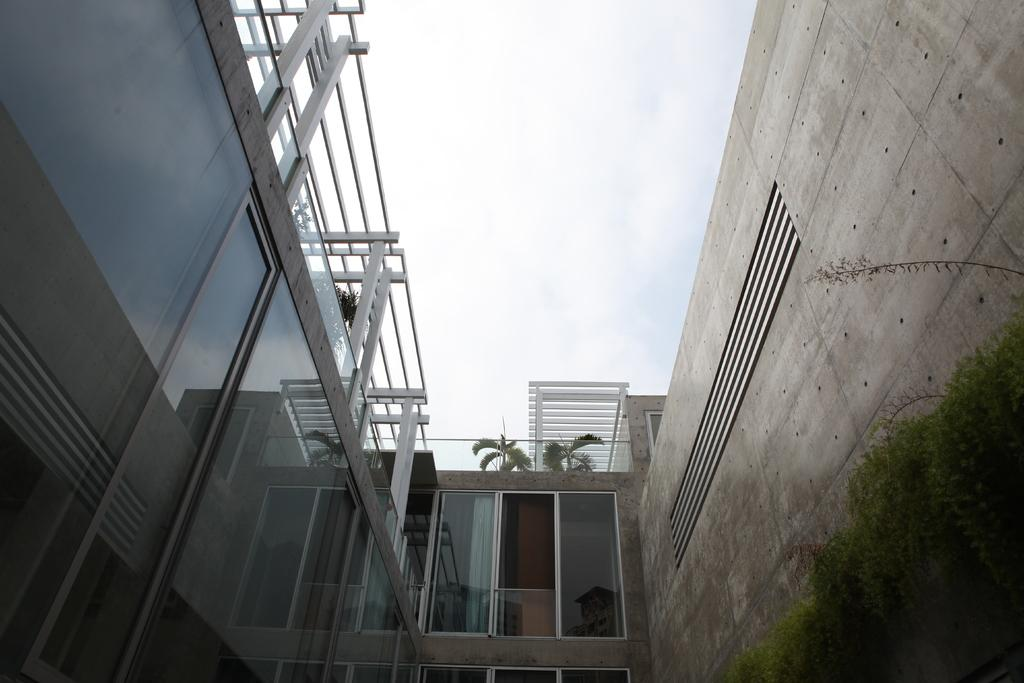What type of structure is present in the image? There is a building in the image. What feature can be seen on the building? The building has windows. What is located near the building? There is a fence in the image. What type of natural elements are visible in the image? There are plants visible in the image. What is visible in the background of the image? The sky is visible in the image, and it appears to be cloudy. What type of cracker is being used to disgust the trees in the image? There is no cracker or any indication of disgust present in the image. The image features a building, a fence, plants, and a cloudy sky. 